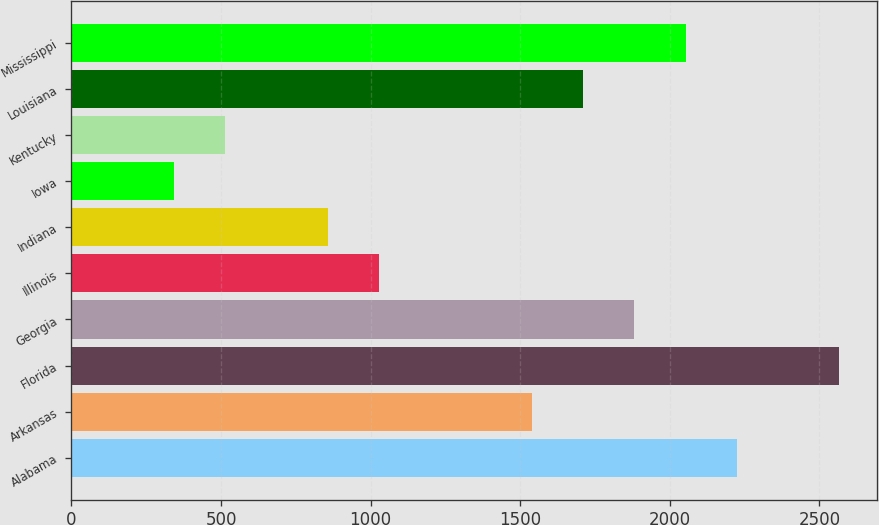<chart> <loc_0><loc_0><loc_500><loc_500><bar_chart><fcel>Alabama<fcel>Arkansas<fcel>Florida<fcel>Georgia<fcel>Illinois<fcel>Indiana<fcel>Iowa<fcel>Kentucky<fcel>Louisiana<fcel>Mississippi<nl><fcel>2223.7<fcel>1540.1<fcel>2565.5<fcel>1881.9<fcel>1027.4<fcel>856.5<fcel>343.8<fcel>514.7<fcel>1711<fcel>2052.8<nl></chart> 